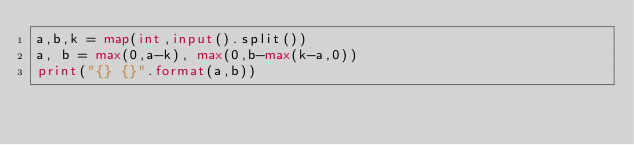<code> <loc_0><loc_0><loc_500><loc_500><_Python_>a,b,k = map(int,input().split())
a, b = max(0,a-k), max(0,b-max(k-a,0))
print("{} {}".format(a,b))</code> 